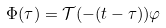Convert formula to latex. <formula><loc_0><loc_0><loc_500><loc_500>\Phi ( \tau ) = \mathcal { T } ( - ( t - \tau ) ) \varphi</formula> 